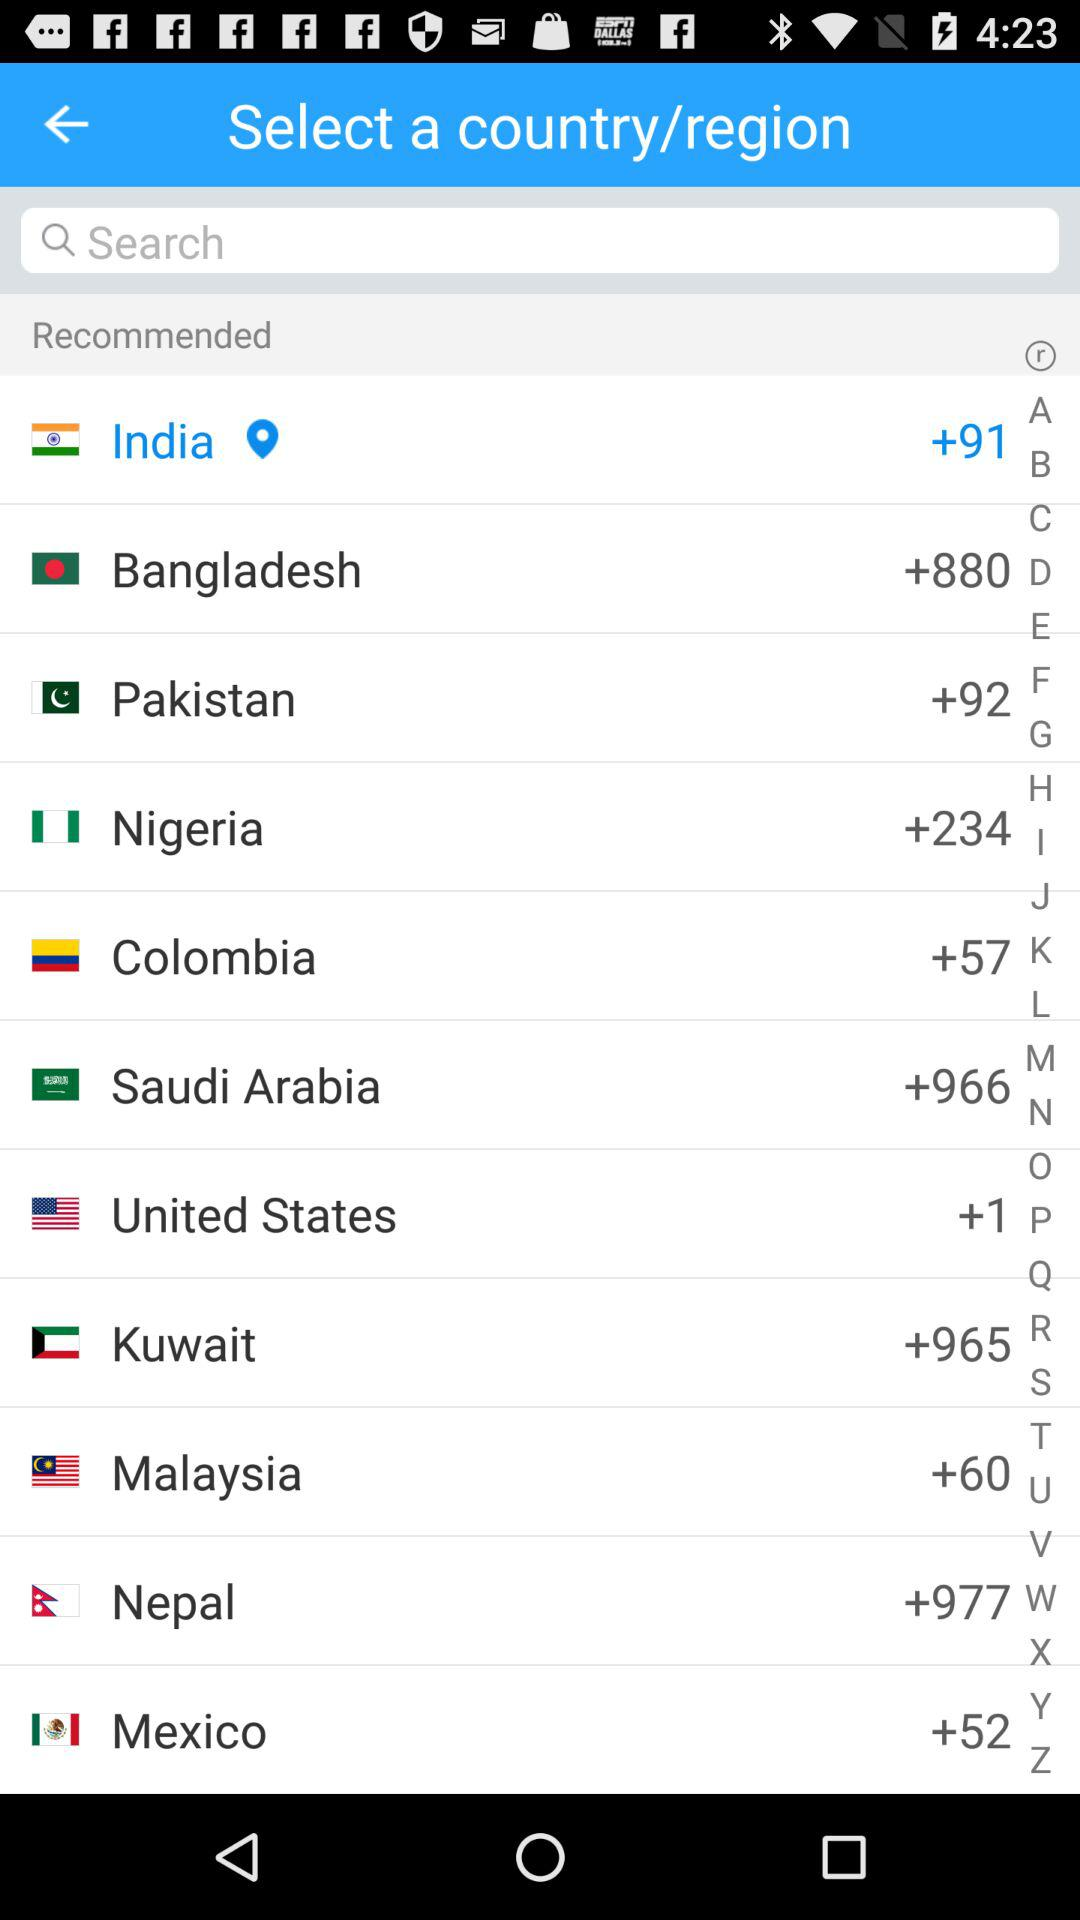What is the country code of Nepal? The country code of Nepal is +977. 